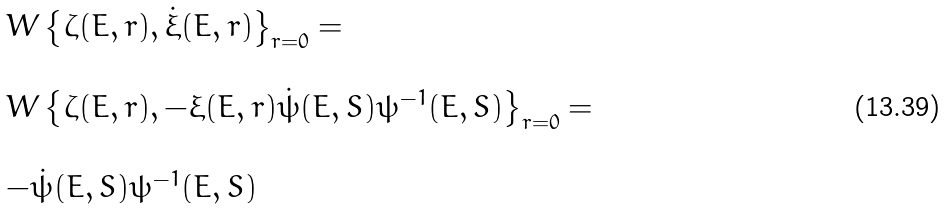Convert formula to latex. <formula><loc_0><loc_0><loc_500><loc_500>\begin{array} { l } W \left \{ \zeta ( E , r ) , \dot { \xi } ( E , r ) \right \} _ { r = 0 } = \\ \\ W \left \{ \zeta ( E , r ) , - \xi ( E , r ) \dot { \psi } ( E , S ) \psi ^ { - 1 } ( E , S ) \right \} _ { r = 0 } = \\ \\ - \dot { \psi } ( E , S ) \psi ^ { - 1 } ( E , S ) \end{array}</formula> 